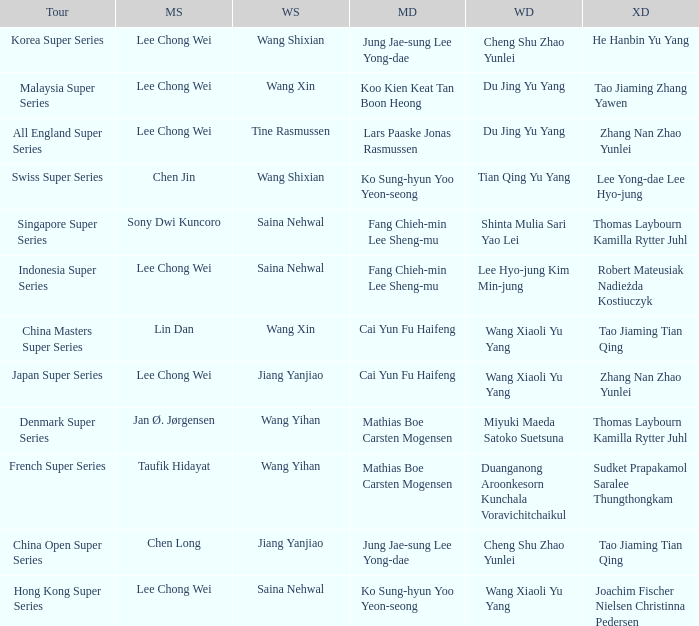Who is the womens doubles on the tour french super series? Duanganong Aroonkesorn Kunchala Voravichitchaikul. Parse the table in full. {'header': ['Tour', 'MS', 'WS', 'MD', 'WD', 'XD'], 'rows': [['Korea Super Series', 'Lee Chong Wei', 'Wang Shixian', 'Jung Jae-sung Lee Yong-dae', 'Cheng Shu Zhao Yunlei', 'He Hanbin Yu Yang'], ['Malaysia Super Series', 'Lee Chong Wei', 'Wang Xin', 'Koo Kien Keat Tan Boon Heong', 'Du Jing Yu Yang', 'Tao Jiaming Zhang Yawen'], ['All England Super Series', 'Lee Chong Wei', 'Tine Rasmussen', 'Lars Paaske Jonas Rasmussen', 'Du Jing Yu Yang', 'Zhang Nan Zhao Yunlei'], ['Swiss Super Series', 'Chen Jin', 'Wang Shixian', 'Ko Sung-hyun Yoo Yeon-seong', 'Tian Qing Yu Yang', 'Lee Yong-dae Lee Hyo-jung'], ['Singapore Super Series', 'Sony Dwi Kuncoro', 'Saina Nehwal', 'Fang Chieh-min Lee Sheng-mu', 'Shinta Mulia Sari Yao Lei', 'Thomas Laybourn Kamilla Rytter Juhl'], ['Indonesia Super Series', 'Lee Chong Wei', 'Saina Nehwal', 'Fang Chieh-min Lee Sheng-mu', 'Lee Hyo-jung Kim Min-jung', 'Robert Mateusiak Nadieżda Kostiuczyk'], ['China Masters Super Series', 'Lin Dan', 'Wang Xin', 'Cai Yun Fu Haifeng', 'Wang Xiaoli Yu Yang', 'Tao Jiaming Tian Qing'], ['Japan Super Series', 'Lee Chong Wei', 'Jiang Yanjiao', 'Cai Yun Fu Haifeng', 'Wang Xiaoli Yu Yang', 'Zhang Nan Zhao Yunlei'], ['Denmark Super Series', 'Jan Ø. Jørgensen', 'Wang Yihan', 'Mathias Boe Carsten Mogensen', 'Miyuki Maeda Satoko Suetsuna', 'Thomas Laybourn Kamilla Rytter Juhl'], ['French Super Series', 'Taufik Hidayat', 'Wang Yihan', 'Mathias Boe Carsten Mogensen', 'Duanganong Aroonkesorn Kunchala Voravichitchaikul', 'Sudket Prapakamol Saralee Thungthongkam'], ['China Open Super Series', 'Chen Long', 'Jiang Yanjiao', 'Jung Jae-sung Lee Yong-dae', 'Cheng Shu Zhao Yunlei', 'Tao Jiaming Tian Qing'], ['Hong Kong Super Series', 'Lee Chong Wei', 'Saina Nehwal', 'Ko Sung-hyun Yoo Yeon-seong', 'Wang Xiaoli Yu Yang', 'Joachim Fischer Nielsen Christinna Pedersen']]} 